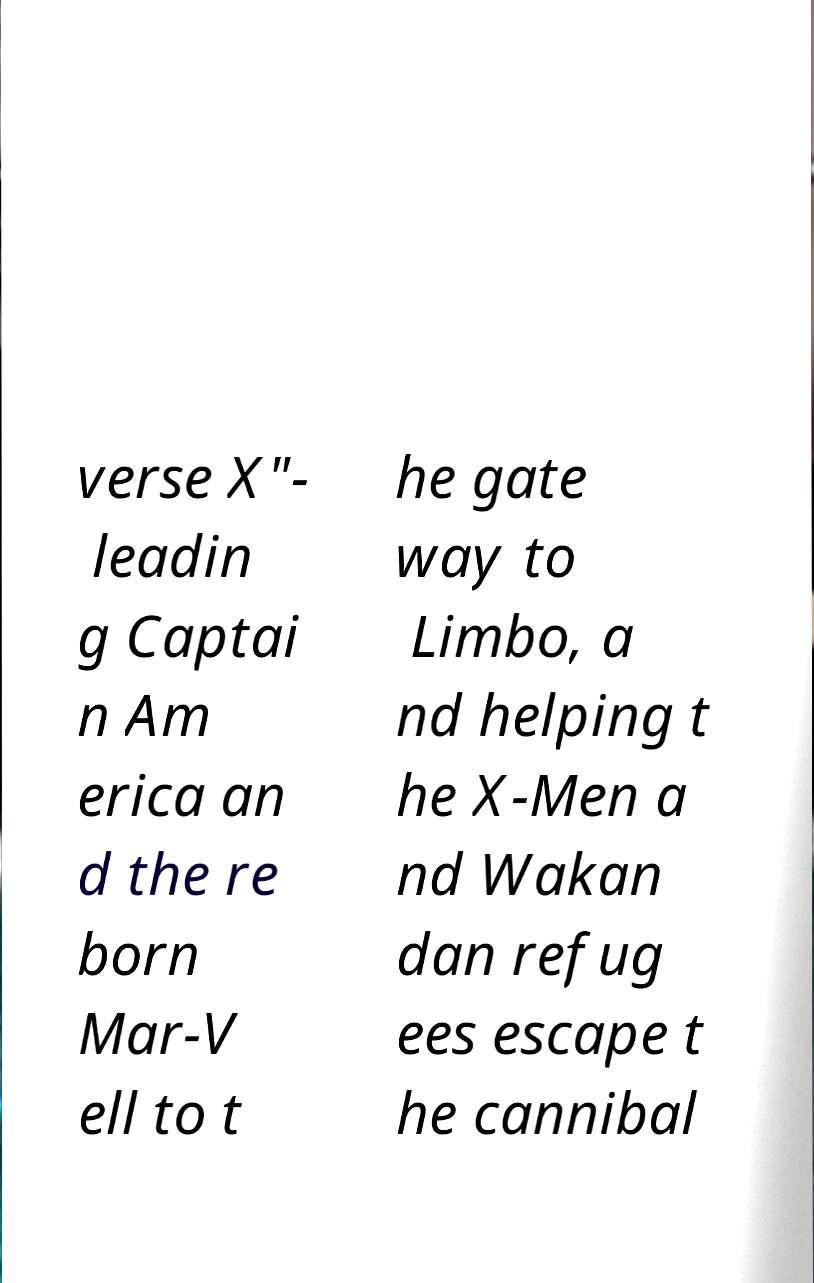Could you extract and type out the text from this image? verse X"- leadin g Captai n Am erica an d the re born Mar-V ell to t he gate way to Limbo, a nd helping t he X-Men a nd Wakan dan refug ees escape t he cannibal 